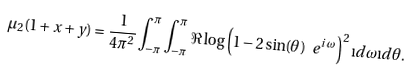Convert formula to latex. <formula><loc_0><loc_0><loc_500><loc_500>\mu _ { 2 } ( 1 + x + y ) = \frac { 1 } { 4 \pi ^ { 2 } } \int _ { - \pi } ^ { \pi } \int _ { - \pi } ^ { \pi } \Re \log \left ( 1 - 2 \sin ( \theta ) \ e ^ { i \, \omega } \right ) ^ { 2 } \i d \omega \i d \theta .</formula> 